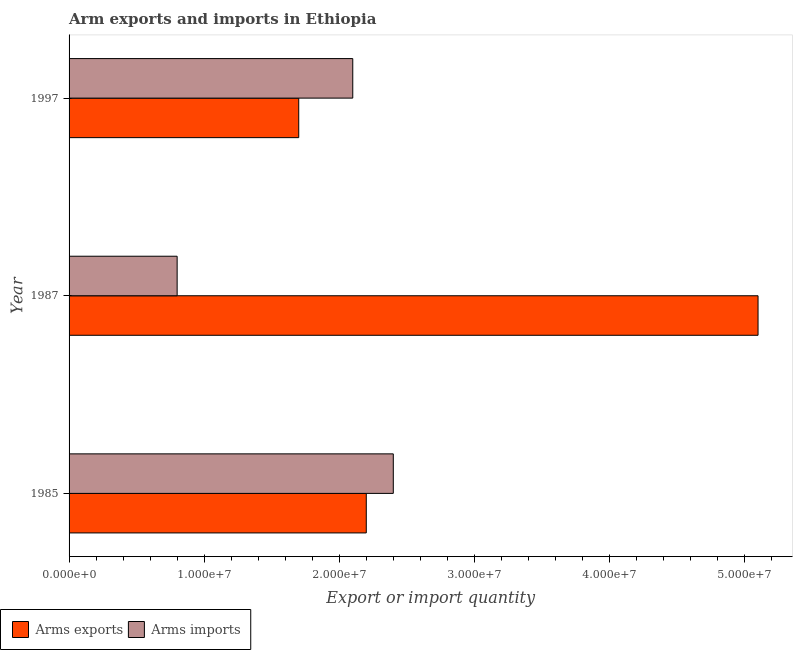How many different coloured bars are there?
Your answer should be compact. 2. How many groups of bars are there?
Give a very brief answer. 3. Are the number of bars per tick equal to the number of legend labels?
Ensure brevity in your answer.  Yes. What is the arms exports in 1985?
Offer a terse response. 2.20e+07. Across all years, what is the maximum arms imports?
Your answer should be compact. 2.40e+07. Across all years, what is the minimum arms imports?
Keep it short and to the point. 8.00e+06. In which year was the arms imports maximum?
Keep it short and to the point. 1985. In which year was the arms imports minimum?
Provide a short and direct response. 1987. What is the total arms exports in the graph?
Your answer should be very brief. 9.00e+07. What is the difference between the arms exports in 1985 and that in 1997?
Ensure brevity in your answer.  5.00e+06. What is the difference between the arms imports in 1985 and the arms exports in 1997?
Ensure brevity in your answer.  7.00e+06. What is the average arms imports per year?
Offer a very short reply. 1.77e+07. In the year 1987, what is the difference between the arms exports and arms imports?
Ensure brevity in your answer.  4.30e+07. In how many years, is the arms exports greater than 40000000 ?
Your response must be concise. 1. What is the ratio of the arms imports in 1987 to that in 1997?
Your response must be concise. 0.38. Is the arms imports in 1985 less than that in 1997?
Offer a terse response. No. What is the difference between the highest and the lowest arms imports?
Your answer should be very brief. 1.60e+07. Is the sum of the arms exports in 1987 and 1997 greater than the maximum arms imports across all years?
Your response must be concise. Yes. What does the 1st bar from the top in 1997 represents?
Ensure brevity in your answer.  Arms imports. What does the 2nd bar from the bottom in 1997 represents?
Provide a succinct answer. Arms imports. How many bars are there?
Your answer should be very brief. 6. Are all the bars in the graph horizontal?
Offer a terse response. Yes. How many years are there in the graph?
Make the answer very short. 3. What is the difference between two consecutive major ticks on the X-axis?
Offer a very short reply. 1.00e+07. Are the values on the major ticks of X-axis written in scientific E-notation?
Your response must be concise. Yes. Does the graph contain grids?
Provide a succinct answer. No. How many legend labels are there?
Your answer should be very brief. 2. How are the legend labels stacked?
Ensure brevity in your answer.  Horizontal. What is the title of the graph?
Your response must be concise. Arm exports and imports in Ethiopia. Does "Frequency of shipment arrival" appear as one of the legend labels in the graph?
Provide a short and direct response. No. What is the label or title of the X-axis?
Give a very brief answer. Export or import quantity. What is the label or title of the Y-axis?
Your response must be concise. Year. What is the Export or import quantity of Arms exports in 1985?
Make the answer very short. 2.20e+07. What is the Export or import quantity of Arms imports in 1985?
Keep it short and to the point. 2.40e+07. What is the Export or import quantity in Arms exports in 1987?
Provide a succinct answer. 5.10e+07. What is the Export or import quantity in Arms imports in 1987?
Provide a short and direct response. 8.00e+06. What is the Export or import quantity in Arms exports in 1997?
Your answer should be compact. 1.70e+07. What is the Export or import quantity in Arms imports in 1997?
Make the answer very short. 2.10e+07. Across all years, what is the maximum Export or import quantity of Arms exports?
Your response must be concise. 5.10e+07. Across all years, what is the maximum Export or import quantity of Arms imports?
Your answer should be compact. 2.40e+07. Across all years, what is the minimum Export or import quantity in Arms exports?
Your response must be concise. 1.70e+07. Across all years, what is the minimum Export or import quantity in Arms imports?
Your answer should be compact. 8.00e+06. What is the total Export or import quantity in Arms exports in the graph?
Give a very brief answer. 9.00e+07. What is the total Export or import quantity in Arms imports in the graph?
Provide a short and direct response. 5.30e+07. What is the difference between the Export or import quantity in Arms exports in 1985 and that in 1987?
Provide a short and direct response. -2.90e+07. What is the difference between the Export or import quantity in Arms imports in 1985 and that in 1987?
Your answer should be compact. 1.60e+07. What is the difference between the Export or import quantity of Arms imports in 1985 and that in 1997?
Offer a terse response. 3.00e+06. What is the difference between the Export or import quantity in Arms exports in 1987 and that in 1997?
Provide a short and direct response. 3.40e+07. What is the difference between the Export or import quantity of Arms imports in 1987 and that in 1997?
Make the answer very short. -1.30e+07. What is the difference between the Export or import quantity in Arms exports in 1985 and the Export or import quantity in Arms imports in 1987?
Keep it short and to the point. 1.40e+07. What is the difference between the Export or import quantity of Arms exports in 1987 and the Export or import quantity of Arms imports in 1997?
Provide a short and direct response. 3.00e+07. What is the average Export or import quantity in Arms exports per year?
Your answer should be very brief. 3.00e+07. What is the average Export or import quantity of Arms imports per year?
Ensure brevity in your answer.  1.77e+07. In the year 1985, what is the difference between the Export or import quantity of Arms exports and Export or import quantity of Arms imports?
Provide a short and direct response. -2.00e+06. In the year 1987, what is the difference between the Export or import quantity in Arms exports and Export or import quantity in Arms imports?
Offer a terse response. 4.30e+07. In the year 1997, what is the difference between the Export or import quantity of Arms exports and Export or import quantity of Arms imports?
Ensure brevity in your answer.  -4.00e+06. What is the ratio of the Export or import quantity in Arms exports in 1985 to that in 1987?
Make the answer very short. 0.43. What is the ratio of the Export or import quantity in Arms exports in 1985 to that in 1997?
Provide a short and direct response. 1.29. What is the ratio of the Export or import quantity of Arms imports in 1987 to that in 1997?
Provide a succinct answer. 0.38. What is the difference between the highest and the second highest Export or import quantity in Arms exports?
Provide a short and direct response. 2.90e+07. What is the difference between the highest and the lowest Export or import quantity in Arms exports?
Make the answer very short. 3.40e+07. What is the difference between the highest and the lowest Export or import quantity of Arms imports?
Ensure brevity in your answer.  1.60e+07. 